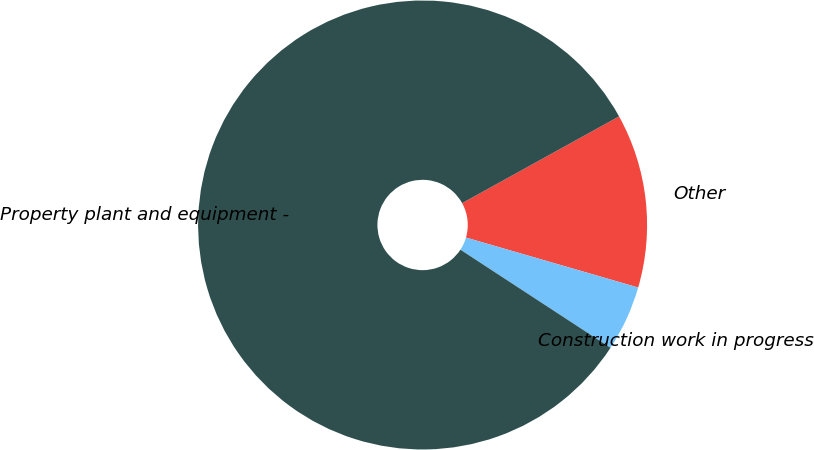Convert chart to OTSL. <chart><loc_0><loc_0><loc_500><loc_500><pie_chart><fcel>Other<fcel>Construction work in progress<fcel>Property plant and equipment -<nl><fcel>12.53%<fcel>4.72%<fcel>82.75%<nl></chart> 